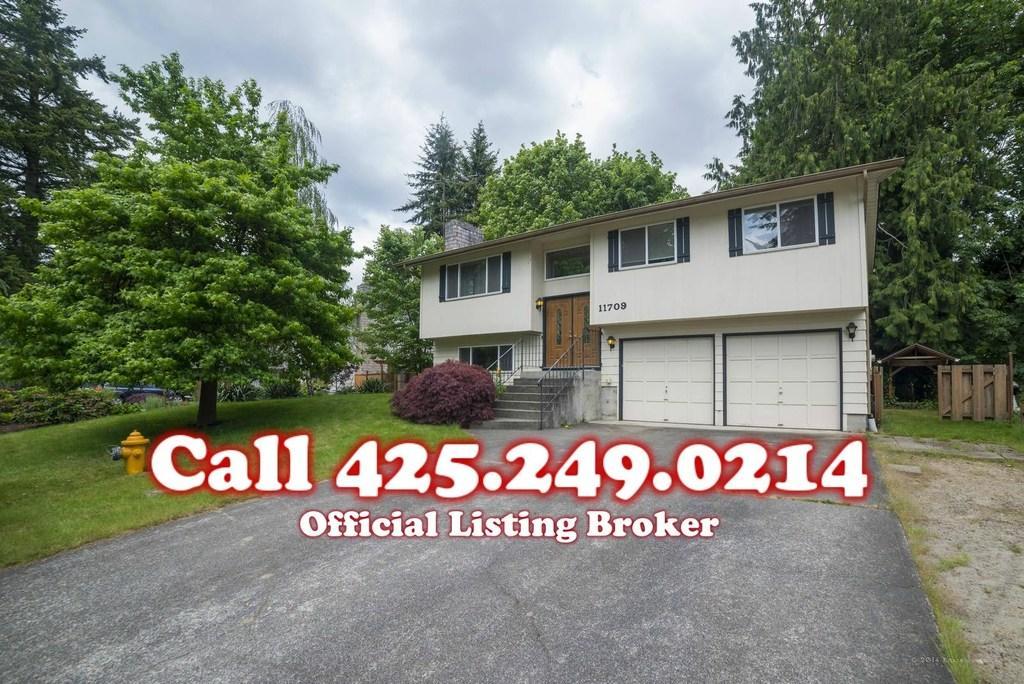Describe this image in one or two sentences. In this image we can see a house. Behind house trees are there. The sky is covered with clouds. Left side of the image grassy land and fire hydrant is present. Bottom of the image road is there and on the image watermark is present. 